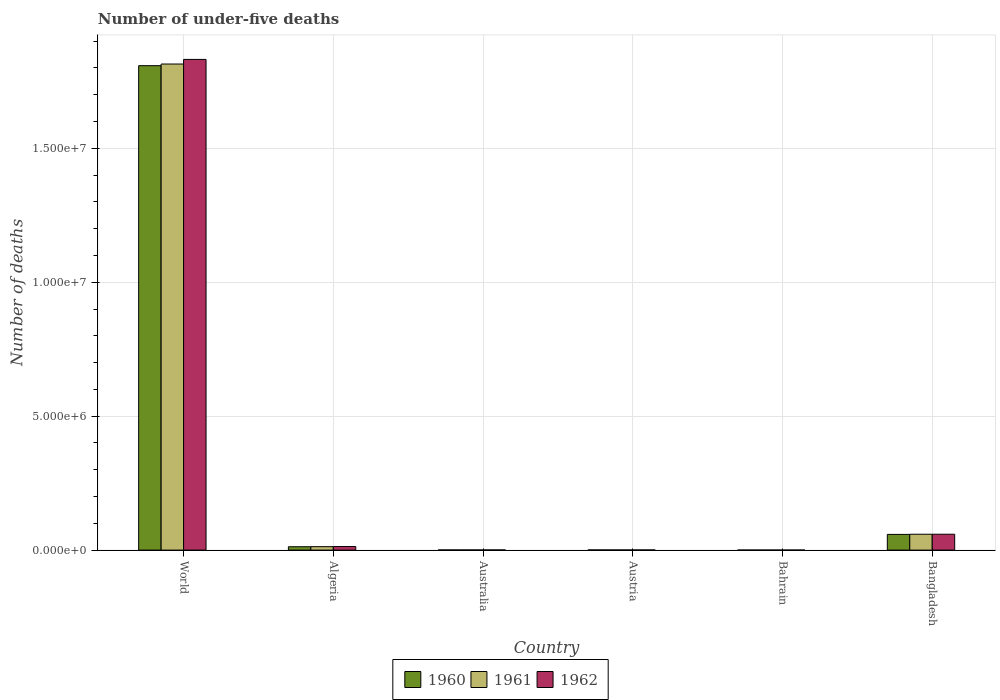How many groups of bars are there?
Provide a succinct answer. 6. How many bars are there on the 2nd tick from the left?
Ensure brevity in your answer.  3. What is the label of the 2nd group of bars from the left?
Give a very brief answer. Algeria. What is the number of under-five deaths in 1961 in Bahrain?
Your answer should be very brief. 1323. Across all countries, what is the maximum number of under-five deaths in 1961?
Make the answer very short. 1.81e+07. Across all countries, what is the minimum number of under-five deaths in 1960?
Give a very brief answer. 1410. In which country was the number of under-five deaths in 1962 minimum?
Your response must be concise. Bahrain. What is the total number of under-five deaths in 1962 in the graph?
Your response must be concise. 1.91e+07. What is the difference between the number of under-five deaths in 1961 in Algeria and that in Bahrain?
Your answer should be very brief. 1.27e+05. What is the difference between the number of under-five deaths in 1961 in Austria and the number of under-five deaths in 1962 in World?
Make the answer very short. -1.83e+07. What is the average number of under-five deaths in 1961 per country?
Provide a succinct answer. 3.15e+06. What is the difference between the number of under-five deaths of/in 1961 and number of under-five deaths of/in 1962 in World?
Offer a very short reply. -1.72e+05. In how many countries, is the number of under-five deaths in 1960 greater than 3000000?
Offer a very short reply. 1. What is the ratio of the number of under-five deaths in 1960 in Algeria to that in Australia?
Your response must be concise. 21.72. Is the number of under-five deaths in 1960 in Austria less than that in Bangladesh?
Offer a terse response. Yes. Is the difference between the number of under-five deaths in 1961 in Bahrain and Bangladesh greater than the difference between the number of under-five deaths in 1962 in Bahrain and Bangladesh?
Your response must be concise. Yes. What is the difference between the highest and the second highest number of under-five deaths in 1962?
Your answer should be compact. -4.59e+05. What is the difference between the highest and the lowest number of under-five deaths in 1961?
Your response must be concise. 1.81e+07. In how many countries, is the number of under-five deaths in 1960 greater than the average number of under-five deaths in 1960 taken over all countries?
Your answer should be very brief. 1. What is the difference between two consecutive major ticks on the Y-axis?
Offer a very short reply. 5.00e+06. Are the values on the major ticks of Y-axis written in scientific E-notation?
Keep it short and to the point. Yes. Does the graph contain any zero values?
Provide a succinct answer. No. Does the graph contain grids?
Give a very brief answer. Yes. Where does the legend appear in the graph?
Keep it short and to the point. Bottom center. What is the title of the graph?
Provide a succinct answer. Number of under-five deaths. What is the label or title of the Y-axis?
Give a very brief answer. Number of deaths. What is the Number of deaths in 1960 in World?
Your answer should be compact. 1.81e+07. What is the Number of deaths of 1961 in World?
Provide a short and direct response. 1.81e+07. What is the Number of deaths of 1962 in World?
Keep it short and to the point. 1.83e+07. What is the Number of deaths of 1960 in Algeria?
Your answer should be compact. 1.25e+05. What is the Number of deaths in 1961 in Algeria?
Your answer should be very brief. 1.28e+05. What is the Number of deaths in 1962 in Algeria?
Offer a terse response. 1.33e+05. What is the Number of deaths of 1960 in Australia?
Provide a short and direct response. 5775. What is the Number of deaths in 1961 in Australia?
Ensure brevity in your answer.  5722. What is the Number of deaths of 1962 in Australia?
Provide a short and direct response. 5592. What is the Number of deaths of 1960 in Austria?
Provide a short and direct response. 5754. What is the Number of deaths in 1961 in Austria?
Keep it short and to the point. 5502. What is the Number of deaths of 1962 in Austria?
Give a very brief answer. 5183. What is the Number of deaths of 1960 in Bahrain?
Your answer should be compact. 1410. What is the Number of deaths in 1961 in Bahrain?
Your answer should be compact. 1323. What is the Number of deaths in 1962 in Bahrain?
Offer a very short reply. 1207. What is the Number of deaths in 1960 in Bangladesh?
Offer a terse response. 5.86e+05. What is the Number of deaths in 1961 in Bangladesh?
Your answer should be compact. 5.92e+05. What is the Number of deaths of 1962 in Bangladesh?
Give a very brief answer. 5.92e+05. Across all countries, what is the maximum Number of deaths in 1960?
Give a very brief answer. 1.81e+07. Across all countries, what is the maximum Number of deaths in 1961?
Give a very brief answer. 1.81e+07. Across all countries, what is the maximum Number of deaths in 1962?
Give a very brief answer. 1.83e+07. Across all countries, what is the minimum Number of deaths of 1960?
Give a very brief answer. 1410. Across all countries, what is the minimum Number of deaths of 1961?
Offer a terse response. 1323. Across all countries, what is the minimum Number of deaths in 1962?
Keep it short and to the point. 1207. What is the total Number of deaths of 1960 in the graph?
Offer a very short reply. 1.88e+07. What is the total Number of deaths of 1961 in the graph?
Keep it short and to the point. 1.89e+07. What is the total Number of deaths in 1962 in the graph?
Offer a very short reply. 1.91e+07. What is the difference between the Number of deaths in 1960 in World and that in Algeria?
Provide a succinct answer. 1.80e+07. What is the difference between the Number of deaths in 1961 in World and that in Algeria?
Your response must be concise. 1.80e+07. What is the difference between the Number of deaths of 1962 in World and that in Algeria?
Ensure brevity in your answer.  1.82e+07. What is the difference between the Number of deaths of 1960 in World and that in Australia?
Ensure brevity in your answer.  1.81e+07. What is the difference between the Number of deaths of 1961 in World and that in Australia?
Provide a short and direct response. 1.81e+07. What is the difference between the Number of deaths in 1962 in World and that in Australia?
Your answer should be compact. 1.83e+07. What is the difference between the Number of deaths in 1960 in World and that in Austria?
Ensure brevity in your answer.  1.81e+07. What is the difference between the Number of deaths of 1961 in World and that in Austria?
Make the answer very short. 1.81e+07. What is the difference between the Number of deaths in 1962 in World and that in Austria?
Keep it short and to the point. 1.83e+07. What is the difference between the Number of deaths in 1960 in World and that in Bahrain?
Give a very brief answer. 1.81e+07. What is the difference between the Number of deaths of 1961 in World and that in Bahrain?
Your response must be concise. 1.81e+07. What is the difference between the Number of deaths of 1962 in World and that in Bahrain?
Ensure brevity in your answer.  1.83e+07. What is the difference between the Number of deaths in 1960 in World and that in Bangladesh?
Your answer should be very brief. 1.75e+07. What is the difference between the Number of deaths of 1961 in World and that in Bangladesh?
Offer a terse response. 1.76e+07. What is the difference between the Number of deaths of 1962 in World and that in Bangladesh?
Ensure brevity in your answer.  1.77e+07. What is the difference between the Number of deaths of 1960 in Algeria and that in Australia?
Give a very brief answer. 1.20e+05. What is the difference between the Number of deaths of 1961 in Algeria and that in Australia?
Make the answer very short. 1.23e+05. What is the difference between the Number of deaths of 1962 in Algeria and that in Australia?
Ensure brevity in your answer.  1.27e+05. What is the difference between the Number of deaths of 1960 in Algeria and that in Austria?
Your answer should be very brief. 1.20e+05. What is the difference between the Number of deaths of 1961 in Algeria and that in Austria?
Provide a succinct answer. 1.23e+05. What is the difference between the Number of deaths in 1962 in Algeria and that in Austria?
Your answer should be compact. 1.28e+05. What is the difference between the Number of deaths in 1960 in Algeria and that in Bahrain?
Your response must be concise. 1.24e+05. What is the difference between the Number of deaths of 1961 in Algeria and that in Bahrain?
Provide a succinct answer. 1.27e+05. What is the difference between the Number of deaths of 1962 in Algeria and that in Bahrain?
Provide a short and direct response. 1.32e+05. What is the difference between the Number of deaths of 1960 in Algeria and that in Bangladesh?
Offer a very short reply. -4.61e+05. What is the difference between the Number of deaths in 1961 in Algeria and that in Bangladesh?
Your answer should be very brief. -4.64e+05. What is the difference between the Number of deaths of 1962 in Algeria and that in Bangladesh?
Offer a very short reply. -4.59e+05. What is the difference between the Number of deaths in 1960 in Australia and that in Austria?
Ensure brevity in your answer.  21. What is the difference between the Number of deaths in 1961 in Australia and that in Austria?
Make the answer very short. 220. What is the difference between the Number of deaths of 1962 in Australia and that in Austria?
Ensure brevity in your answer.  409. What is the difference between the Number of deaths in 1960 in Australia and that in Bahrain?
Offer a very short reply. 4365. What is the difference between the Number of deaths in 1961 in Australia and that in Bahrain?
Make the answer very short. 4399. What is the difference between the Number of deaths of 1962 in Australia and that in Bahrain?
Offer a very short reply. 4385. What is the difference between the Number of deaths of 1960 in Australia and that in Bangladesh?
Offer a very short reply. -5.81e+05. What is the difference between the Number of deaths of 1961 in Australia and that in Bangladesh?
Offer a very short reply. -5.86e+05. What is the difference between the Number of deaths of 1962 in Australia and that in Bangladesh?
Provide a succinct answer. -5.87e+05. What is the difference between the Number of deaths of 1960 in Austria and that in Bahrain?
Give a very brief answer. 4344. What is the difference between the Number of deaths in 1961 in Austria and that in Bahrain?
Give a very brief answer. 4179. What is the difference between the Number of deaths in 1962 in Austria and that in Bahrain?
Ensure brevity in your answer.  3976. What is the difference between the Number of deaths of 1960 in Austria and that in Bangladesh?
Offer a terse response. -5.81e+05. What is the difference between the Number of deaths in 1961 in Austria and that in Bangladesh?
Offer a terse response. -5.86e+05. What is the difference between the Number of deaths of 1962 in Austria and that in Bangladesh?
Your response must be concise. -5.87e+05. What is the difference between the Number of deaths of 1960 in Bahrain and that in Bangladesh?
Ensure brevity in your answer.  -5.85e+05. What is the difference between the Number of deaths of 1961 in Bahrain and that in Bangladesh?
Provide a short and direct response. -5.91e+05. What is the difference between the Number of deaths in 1962 in Bahrain and that in Bangladesh?
Make the answer very short. -5.91e+05. What is the difference between the Number of deaths in 1960 in World and the Number of deaths in 1961 in Algeria?
Keep it short and to the point. 1.80e+07. What is the difference between the Number of deaths in 1960 in World and the Number of deaths in 1962 in Algeria?
Your answer should be very brief. 1.80e+07. What is the difference between the Number of deaths in 1961 in World and the Number of deaths in 1962 in Algeria?
Keep it short and to the point. 1.80e+07. What is the difference between the Number of deaths of 1960 in World and the Number of deaths of 1961 in Australia?
Ensure brevity in your answer.  1.81e+07. What is the difference between the Number of deaths in 1960 in World and the Number of deaths in 1962 in Australia?
Your response must be concise. 1.81e+07. What is the difference between the Number of deaths of 1961 in World and the Number of deaths of 1962 in Australia?
Make the answer very short. 1.81e+07. What is the difference between the Number of deaths in 1960 in World and the Number of deaths in 1961 in Austria?
Give a very brief answer. 1.81e+07. What is the difference between the Number of deaths of 1960 in World and the Number of deaths of 1962 in Austria?
Provide a succinct answer. 1.81e+07. What is the difference between the Number of deaths of 1961 in World and the Number of deaths of 1962 in Austria?
Give a very brief answer. 1.81e+07. What is the difference between the Number of deaths in 1960 in World and the Number of deaths in 1961 in Bahrain?
Give a very brief answer. 1.81e+07. What is the difference between the Number of deaths in 1960 in World and the Number of deaths in 1962 in Bahrain?
Your answer should be very brief. 1.81e+07. What is the difference between the Number of deaths in 1961 in World and the Number of deaths in 1962 in Bahrain?
Give a very brief answer. 1.81e+07. What is the difference between the Number of deaths in 1960 in World and the Number of deaths in 1961 in Bangladesh?
Ensure brevity in your answer.  1.75e+07. What is the difference between the Number of deaths in 1960 in World and the Number of deaths in 1962 in Bangladesh?
Your answer should be very brief. 1.75e+07. What is the difference between the Number of deaths of 1961 in World and the Number of deaths of 1962 in Bangladesh?
Your answer should be compact. 1.76e+07. What is the difference between the Number of deaths of 1960 in Algeria and the Number of deaths of 1961 in Australia?
Provide a short and direct response. 1.20e+05. What is the difference between the Number of deaths of 1960 in Algeria and the Number of deaths of 1962 in Australia?
Your response must be concise. 1.20e+05. What is the difference between the Number of deaths in 1961 in Algeria and the Number of deaths in 1962 in Australia?
Your answer should be compact. 1.23e+05. What is the difference between the Number of deaths of 1960 in Algeria and the Number of deaths of 1961 in Austria?
Ensure brevity in your answer.  1.20e+05. What is the difference between the Number of deaths of 1960 in Algeria and the Number of deaths of 1962 in Austria?
Give a very brief answer. 1.20e+05. What is the difference between the Number of deaths of 1961 in Algeria and the Number of deaths of 1962 in Austria?
Your response must be concise. 1.23e+05. What is the difference between the Number of deaths of 1960 in Algeria and the Number of deaths of 1961 in Bahrain?
Your answer should be very brief. 1.24e+05. What is the difference between the Number of deaths in 1960 in Algeria and the Number of deaths in 1962 in Bahrain?
Your response must be concise. 1.24e+05. What is the difference between the Number of deaths in 1961 in Algeria and the Number of deaths in 1962 in Bahrain?
Ensure brevity in your answer.  1.27e+05. What is the difference between the Number of deaths in 1960 in Algeria and the Number of deaths in 1961 in Bangladesh?
Make the answer very short. -4.66e+05. What is the difference between the Number of deaths of 1960 in Algeria and the Number of deaths of 1962 in Bangladesh?
Ensure brevity in your answer.  -4.67e+05. What is the difference between the Number of deaths in 1961 in Algeria and the Number of deaths in 1962 in Bangladesh?
Offer a very short reply. -4.64e+05. What is the difference between the Number of deaths in 1960 in Australia and the Number of deaths in 1961 in Austria?
Your answer should be very brief. 273. What is the difference between the Number of deaths in 1960 in Australia and the Number of deaths in 1962 in Austria?
Provide a short and direct response. 592. What is the difference between the Number of deaths of 1961 in Australia and the Number of deaths of 1962 in Austria?
Give a very brief answer. 539. What is the difference between the Number of deaths in 1960 in Australia and the Number of deaths in 1961 in Bahrain?
Provide a short and direct response. 4452. What is the difference between the Number of deaths in 1960 in Australia and the Number of deaths in 1962 in Bahrain?
Ensure brevity in your answer.  4568. What is the difference between the Number of deaths of 1961 in Australia and the Number of deaths of 1962 in Bahrain?
Keep it short and to the point. 4515. What is the difference between the Number of deaths of 1960 in Australia and the Number of deaths of 1961 in Bangladesh?
Your response must be concise. -5.86e+05. What is the difference between the Number of deaths of 1960 in Australia and the Number of deaths of 1962 in Bangladesh?
Keep it short and to the point. -5.87e+05. What is the difference between the Number of deaths in 1961 in Australia and the Number of deaths in 1962 in Bangladesh?
Offer a terse response. -5.87e+05. What is the difference between the Number of deaths of 1960 in Austria and the Number of deaths of 1961 in Bahrain?
Keep it short and to the point. 4431. What is the difference between the Number of deaths of 1960 in Austria and the Number of deaths of 1962 in Bahrain?
Your response must be concise. 4547. What is the difference between the Number of deaths of 1961 in Austria and the Number of deaths of 1962 in Bahrain?
Offer a very short reply. 4295. What is the difference between the Number of deaths in 1960 in Austria and the Number of deaths in 1961 in Bangladesh?
Ensure brevity in your answer.  -5.86e+05. What is the difference between the Number of deaths in 1960 in Austria and the Number of deaths in 1962 in Bangladesh?
Ensure brevity in your answer.  -5.87e+05. What is the difference between the Number of deaths in 1961 in Austria and the Number of deaths in 1962 in Bangladesh?
Your answer should be compact. -5.87e+05. What is the difference between the Number of deaths in 1960 in Bahrain and the Number of deaths in 1961 in Bangladesh?
Your answer should be compact. -5.90e+05. What is the difference between the Number of deaths in 1960 in Bahrain and the Number of deaths in 1962 in Bangladesh?
Ensure brevity in your answer.  -5.91e+05. What is the difference between the Number of deaths of 1961 in Bahrain and the Number of deaths of 1962 in Bangladesh?
Make the answer very short. -5.91e+05. What is the average Number of deaths of 1960 per country?
Offer a very short reply. 3.13e+06. What is the average Number of deaths of 1961 per country?
Keep it short and to the point. 3.15e+06. What is the average Number of deaths of 1962 per country?
Make the answer very short. 3.18e+06. What is the difference between the Number of deaths in 1960 and Number of deaths in 1961 in World?
Your response must be concise. -6.21e+04. What is the difference between the Number of deaths of 1960 and Number of deaths of 1962 in World?
Make the answer very short. -2.34e+05. What is the difference between the Number of deaths of 1961 and Number of deaths of 1962 in World?
Offer a terse response. -1.72e+05. What is the difference between the Number of deaths in 1960 and Number of deaths in 1961 in Algeria?
Make the answer very short. -2789. What is the difference between the Number of deaths of 1960 and Number of deaths of 1962 in Algeria?
Keep it short and to the point. -7580. What is the difference between the Number of deaths of 1961 and Number of deaths of 1962 in Algeria?
Your response must be concise. -4791. What is the difference between the Number of deaths of 1960 and Number of deaths of 1962 in Australia?
Give a very brief answer. 183. What is the difference between the Number of deaths in 1961 and Number of deaths in 1962 in Australia?
Keep it short and to the point. 130. What is the difference between the Number of deaths of 1960 and Number of deaths of 1961 in Austria?
Provide a short and direct response. 252. What is the difference between the Number of deaths of 1960 and Number of deaths of 1962 in Austria?
Your response must be concise. 571. What is the difference between the Number of deaths in 1961 and Number of deaths in 1962 in Austria?
Provide a succinct answer. 319. What is the difference between the Number of deaths in 1960 and Number of deaths in 1961 in Bahrain?
Ensure brevity in your answer.  87. What is the difference between the Number of deaths of 1960 and Number of deaths of 1962 in Bahrain?
Provide a succinct answer. 203. What is the difference between the Number of deaths of 1961 and Number of deaths of 1962 in Bahrain?
Your answer should be compact. 116. What is the difference between the Number of deaths of 1960 and Number of deaths of 1961 in Bangladesh?
Your answer should be compact. -5561. What is the difference between the Number of deaths of 1960 and Number of deaths of 1962 in Bangladesh?
Your answer should be very brief. -6106. What is the difference between the Number of deaths in 1961 and Number of deaths in 1962 in Bangladesh?
Your answer should be compact. -545. What is the ratio of the Number of deaths of 1960 in World to that in Algeria?
Offer a very short reply. 144.14. What is the ratio of the Number of deaths of 1961 in World to that in Algeria?
Your answer should be very brief. 141.49. What is the ratio of the Number of deaths in 1962 in World to that in Algeria?
Make the answer very short. 137.69. What is the ratio of the Number of deaths of 1960 in World to that in Australia?
Offer a very short reply. 3131.31. What is the ratio of the Number of deaths of 1961 in World to that in Australia?
Offer a terse response. 3171.17. What is the ratio of the Number of deaths in 1962 in World to that in Australia?
Offer a terse response. 3275.65. What is the ratio of the Number of deaths in 1960 in World to that in Austria?
Your response must be concise. 3142.74. What is the ratio of the Number of deaths in 1961 in World to that in Austria?
Your response must be concise. 3297.97. What is the ratio of the Number of deaths in 1962 in World to that in Austria?
Provide a short and direct response. 3534.14. What is the ratio of the Number of deaths of 1960 in World to that in Bahrain?
Your answer should be very brief. 1.28e+04. What is the ratio of the Number of deaths of 1961 in World to that in Bahrain?
Offer a very short reply. 1.37e+04. What is the ratio of the Number of deaths of 1962 in World to that in Bahrain?
Your answer should be compact. 1.52e+04. What is the ratio of the Number of deaths in 1960 in World to that in Bangladesh?
Provide a succinct answer. 30.84. What is the ratio of the Number of deaths of 1961 in World to that in Bangladesh?
Give a very brief answer. 30.66. What is the ratio of the Number of deaths of 1962 in World to that in Bangladesh?
Provide a short and direct response. 30.92. What is the ratio of the Number of deaths in 1960 in Algeria to that in Australia?
Provide a succinct answer. 21.72. What is the ratio of the Number of deaths of 1961 in Algeria to that in Australia?
Provide a short and direct response. 22.41. What is the ratio of the Number of deaths of 1962 in Algeria to that in Australia?
Keep it short and to the point. 23.79. What is the ratio of the Number of deaths in 1960 in Algeria to that in Austria?
Provide a succinct answer. 21.8. What is the ratio of the Number of deaths of 1961 in Algeria to that in Austria?
Provide a short and direct response. 23.31. What is the ratio of the Number of deaths in 1962 in Algeria to that in Austria?
Offer a very short reply. 25.67. What is the ratio of the Number of deaths in 1960 in Algeria to that in Bahrain?
Your answer should be very brief. 88.97. What is the ratio of the Number of deaths of 1961 in Algeria to that in Bahrain?
Provide a short and direct response. 96.93. What is the ratio of the Number of deaths in 1962 in Algeria to that in Bahrain?
Offer a very short reply. 110.22. What is the ratio of the Number of deaths in 1960 in Algeria to that in Bangladesh?
Give a very brief answer. 0.21. What is the ratio of the Number of deaths in 1961 in Algeria to that in Bangladesh?
Your answer should be very brief. 0.22. What is the ratio of the Number of deaths of 1962 in Algeria to that in Bangladesh?
Provide a succinct answer. 0.22. What is the ratio of the Number of deaths in 1960 in Australia to that in Austria?
Provide a succinct answer. 1. What is the ratio of the Number of deaths of 1961 in Australia to that in Austria?
Ensure brevity in your answer.  1.04. What is the ratio of the Number of deaths of 1962 in Australia to that in Austria?
Give a very brief answer. 1.08. What is the ratio of the Number of deaths of 1960 in Australia to that in Bahrain?
Offer a terse response. 4.1. What is the ratio of the Number of deaths of 1961 in Australia to that in Bahrain?
Your answer should be very brief. 4.33. What is the ratio of the Number of deaths of 1962 in Australia to that in Bahrain?
Your answer should be very brief. 4.63. What is the ratio of the Number of deaths in 1960 in Australia to that in Bangladesh?
Keep it short and to the point. 0.01. What is the ratio of the Number of deaths of 1961 in Australia to that in Bangladesh?
Your answer should be compact. 0.01. What is the ratio of the Number of deaths in 1962 in Australia to that in Bangladesh?
Your response must be concise. 0.01. What is the ratio of the Number of deaths in 1960 in Austria to that in Bahrain?
Keep it short and to the point. 4.08. What is the ratio of the Number of deaths of 1961 in Austria to that in Bahrain?
Your response must be concise. 4.16. What is the ratio of the Number of deaths of 1962 in Austria to that in Bahrain?
Your answer should be compact. 4.29. What is the ratio of the Number of deaths of 1960 in Austria to that in Bangladesh?
Ensure brevity in your answer.  0.01. What is the ratio of the Number of deaths of 1961 in Austria to that in Bangladesh?
Ensure brevity in your answer.  0.01. What is the ratio of the Number of deaths in 1962 in Austria to that in Bangladesh?
Your answer should be compact. 0.01. What is the ratio of the Number of deaths in 1960 in Bahrain to that in Bangladesh?
Your answer should be compact. 0. What is the ratio of the Number of deaths of 1961 in Bahrain to that in Bangladesh?
Offer a terse response. 0. What is the ratio of the Number of deaths of 1962 in Bahrain to that in Bangladesh?
Your answer should be compact. 0. What is the difference between the highest and the second highest Number of deaths of 1960?
Give a very brief answer. 1.75e+07. What is the difference between the highest and the second highest Number of deaths in 1961?
Ensure brevity in your answer.  1.76e+07. What is the difference between the highest and the second highest Number of deaths of 1962?
Your answer should be very brief. 1.77e+07. What is the difference between the highest and the lowest Number of deaths in 1960?
Offer a very short reply. 1.81e+07. What is the difference between the highest and the lowest Number of deaths of 1961?
Provide a succinct answer. 1.81e+07. What is the difference between the highest and the lowest Number of deaths in 1962?
Give a very brief answer. 1.83e+07. 